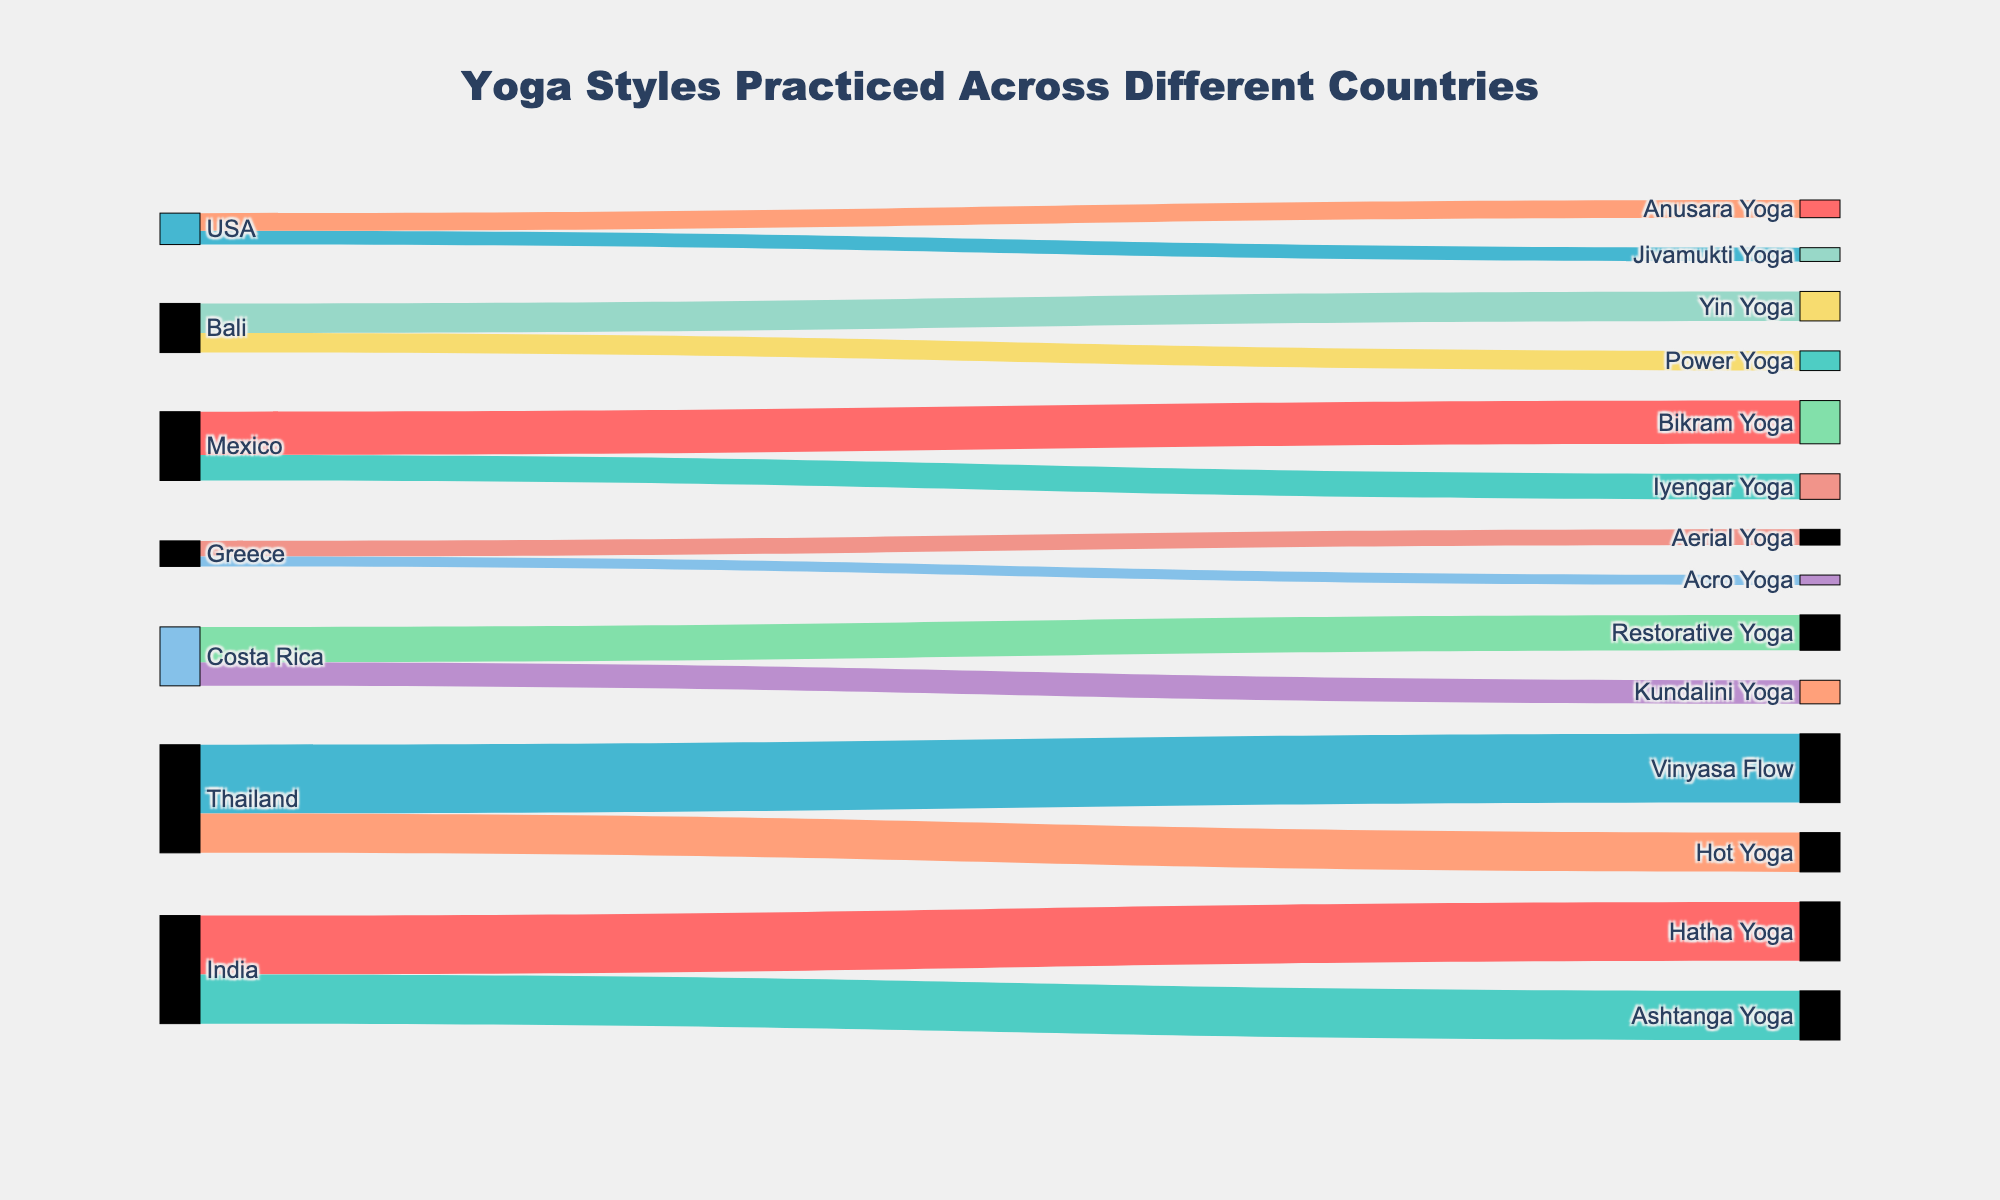what is the most popular yoga style in India? By observing the width of the links stemming from India to various yoga styles in the Sankey Diagram, we can see that Hatha Yoga has the widest link. Therefore, it is the most popular yoga style in India.
Answer: Hatha Yoga Which country has the least variation in yoga styles practiced? Examining the Sankey diagram, the number of connections (links) between a country and yoga styles indicates the variety of yoga styles practiced. India and Thailand each connect to 2 yoga styles, while all other countries also connect to at least 2 yoga styles. Thailand has the least variation because the links are wider, indicating that more people practice those styles.
Answer: Thailand How many countries practice Vinyasa Flow yoga? The link from Thailand leads to Vinyasa Flow. Observing the diagram, no other link from a different country leads to Vinyasa Flow. Therefore, only one country practices Vinyasa Flow.
Answer: 1 Is there a yoga style that is equally practiced in more than one country? By examining all links, we can see that each yoga style is connected to only one country, so no yoga style is equally practiced in more than one country.
Answer: No Which yoga style has the highest practice value in Mexico? Observing the two links from Mexico, we see that Bikram Yoga has a higher value (wider link). Consequently, Bikram Yoga has the highest practice value in Mexico.
Answer: Bikram Yoga What is the combined value for the yoga styles practiced in Greece? The source links from Greece to the yoga styles show values 8 (Aerial Yoga) and 5 (Acro Yoga). Adding them up, 8 + 5 gives a combined value of 13.
Answer: 13 Which country has the maximum total practice value for all yoga styles combined? By summing the values of all links originating from each country, we find: India (55), Thailand (55), Bali (25), Costa Rica (30), Greece (13), Mexico (35), USA (16). Both India and Thailand have the highest total practice value.
Answer: India and Thailand What is the difference in practicing value between Hatha Yoga and Power Yoga? The value for Hatha Yoga is 30, and for Power Yoga is 10. Subtracting these, 30 - 10 provides a difference of 20.
Answer: 20 Which country is associated with Power Yoga practice? Observing the link between the country and the yoga styles, we identify Power Yoga connected to Bali. Therefore, Bali is the country associated with Power Yoga practice.
Answer: Bali 